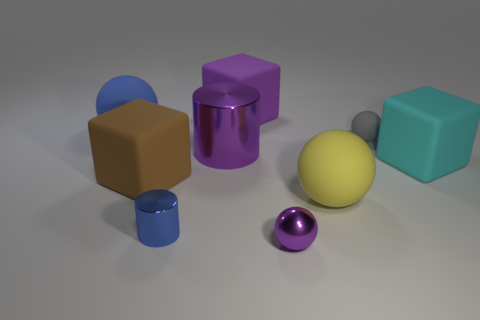Are there any yellow metallic objects of the same shape as the cyan matte object?
Offer a very short reply. No. There is a gray object that is the same size as the purple metal ball; what is its shape?
Your answer should be compact. Sphere. There is a small object that is right of the small purple object; what is its shape?
Make the answer very short. Sphere. Are there fewer purple rubber blocks in front of the brown thing than purple spheres that are in front of the purple shiny cylinder?
Provide a succinct answer. Yes. There is a gray sphere; is its size the same as the cube that is on the right side of the gray object?
Keep it short and to the point. No. What number of purple balls are the same size as the cyan cube?
Make the answer very short. 0. What color is the tiny thing that is made of the same material as the purple cube?
Your response must be concise. Gray. Are there more cyan metal cylinders than big yellow rubber things?
Offer a terse response. No. Is the large yellow object made of the same material as the small blue thing?
Offer a very short reply. No. What is the shape of the large yellow object that is made of the same material as the big blue sphere?
Your response must be concise. Sphere. 